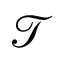Convert formula to latex. <formula><loc_0><loc_0><loc_500><loc_500>\mathcal { T }</formula> 